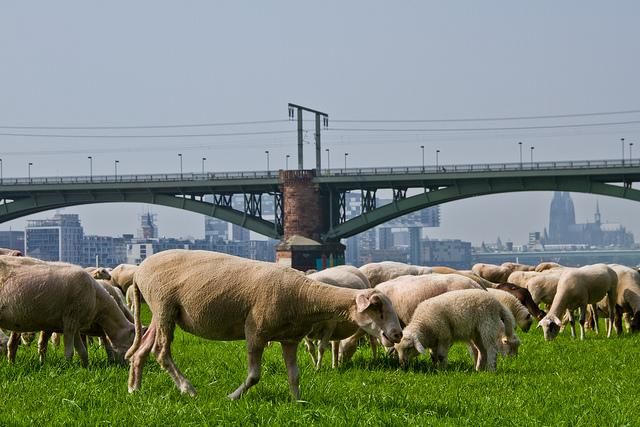What are the animals near?

Choices:
A) basilica
B) bridge
C) cliff
D) ocean bridge 